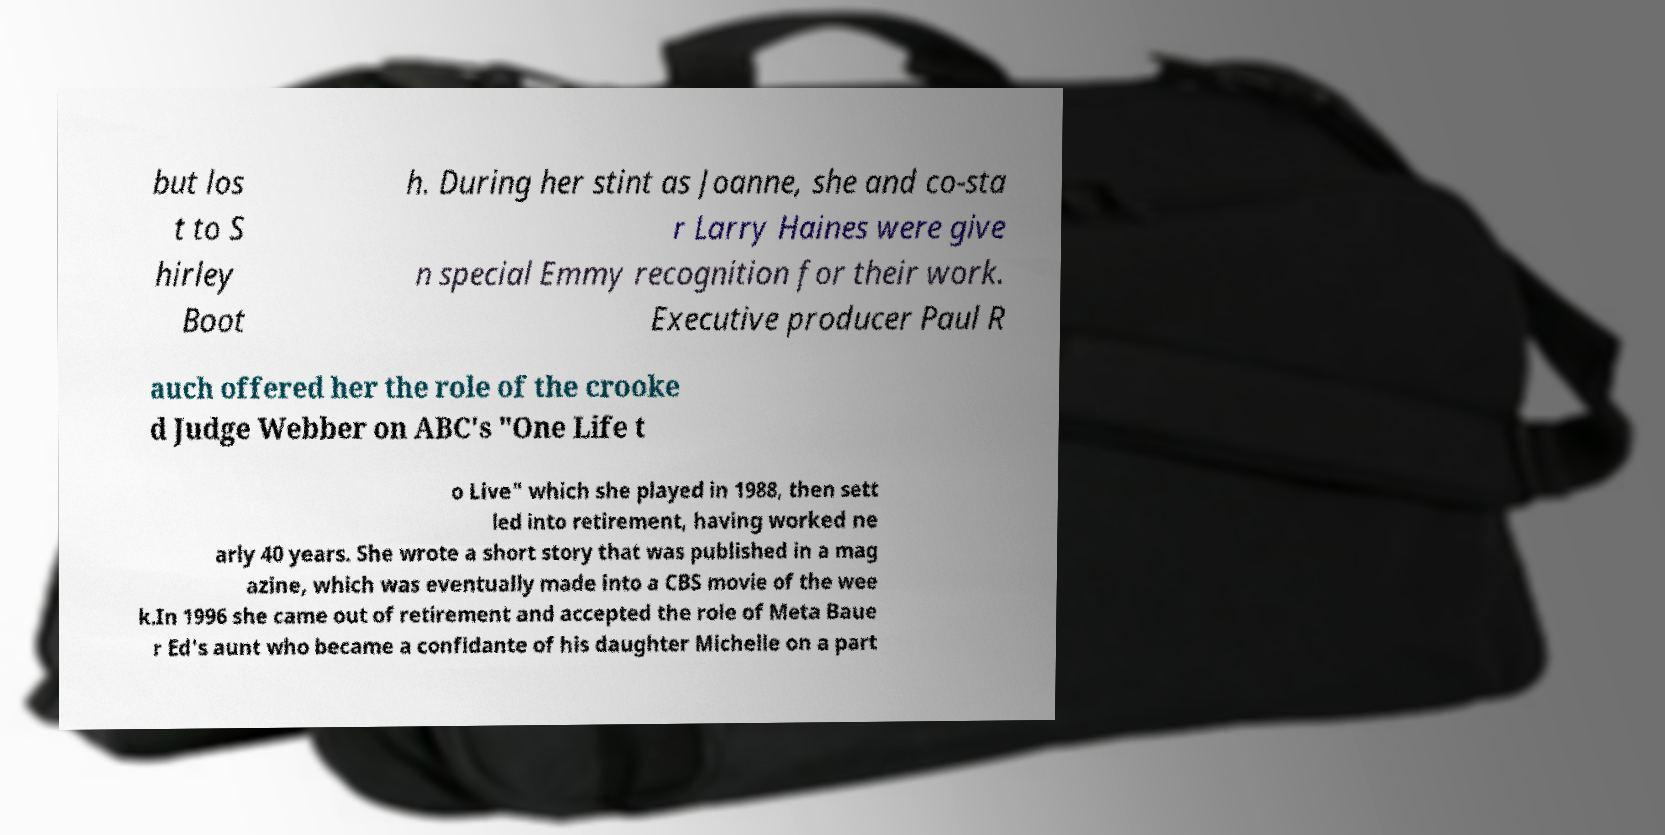I need the written content from this picture converted into text. Can you do that? but los t to S hirley Boot h. During her stint as Joanne, she and co-sta r Larry Haines were give n special Emmy recognition for their work. Executive producer Paul R auch offered her the role of the crooke d Judge Webber on ABC's "One Life t o Live" which she played in 1988, then sett led into retirement, having worked ne arly 40 years. She wrote a short story that was published in a mag azine, which was eventually made into a CBS movie of the wee k.In 1996 she came out of retirement and accepted the role of Meta Baue r Ed's aunt who became a confidante of his daughter Michelle on a part 